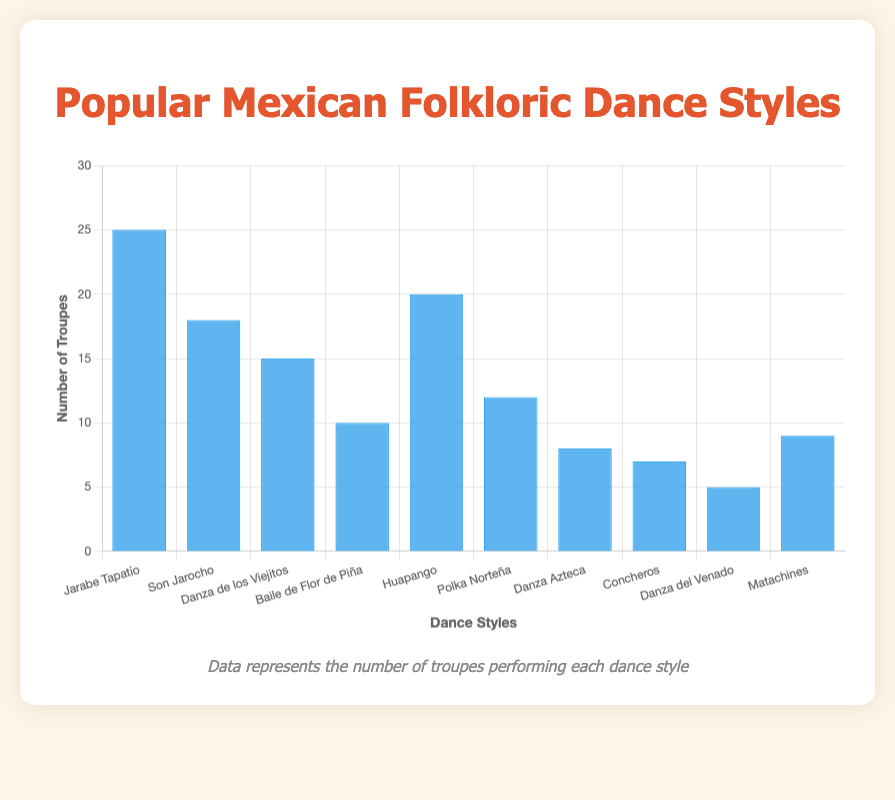What is the most popular Mexican folkloric dance style performed by troupes? To find the most popular dance style, look at the bar with the greatest height. The "Jarabe Tapatío" bar is the tallest.
Answer: Jarabe Tapatío Which dance style is performed by the fewest number of troupes? Look for the shortest bar to find the least popular dance style. The "Danza del Venado" bar is the shortest, indicating the fewest number of troupes.
Answer: Danza del Venado How many more troupes perform "Huapango" compared to "Danza Azteca"? Find the bar heights for both "Huapango" and "Danza Azteca." "Huapango" has 20 troupes, and "Danza Azteca" has 8 troupes. The difference is 20 - 8.
Answer: 12 What is the average number of troupes performing the top three most popular dance styles? Identify the top three styles ("Jarabe Tapatío", "Huapango", and "Son Jarocho") and sum their troupe counts (25 + 20 + 18). Divide by 3 to find the average.
Answer: 21 Are there more troupes performing "Polka Norteña" or "Baile de Flor de Piña"? Compare the heights of the "Polka Norteña" and "Baile de Flor de Piña" bars. "Polka Norteña" has 12 troupes, and "Baile de Flor de Piña" has 10 troupes.
Answer: Polka Norteña What is the total number of troupes performing "Danza de los Viejitos" and "Matachines"? Add the number of troupes for "Danza de los Viejitos" (15) and "Matachines" (9).
Answer: 24 What is the combined number of troupes performing "Concheros", "Danza Azteca", and "Danza del Venado"? Sum the number of troupes for "Concheros" (7), "Danza Azteca" (8), and "Danza del Venado" (5).
Answer: 20 Which dance style has exactly 10 troupes performing it? Identify the bar labeled "Baile de Flor de Piña" which corresponds to 10 troupes.
Answer: Baile de Flor de Piña Between "Son Jarocho", "Danza de los Viejitos", and "Matachines", which style has the median number of troupes? Sort the troupe numbers for these styles: (9, 15, 18). The median value is the middle number.
Answer: Danza de los Viejitos How many more troupes perform the "Jarabe Tapatío" compared to the "Danza de los Viejitos"? Subtract the number of troupes for "Danza de los Viejitos" (15) from those for "Jarabe Tapatío" (25).
Answer: 10 